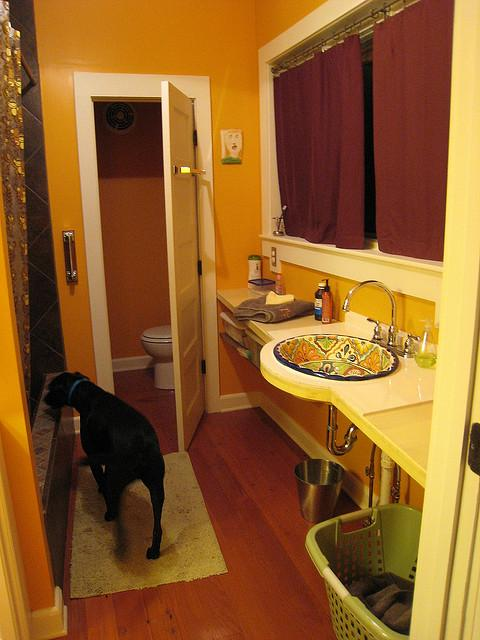What type of dog is this? black lab 